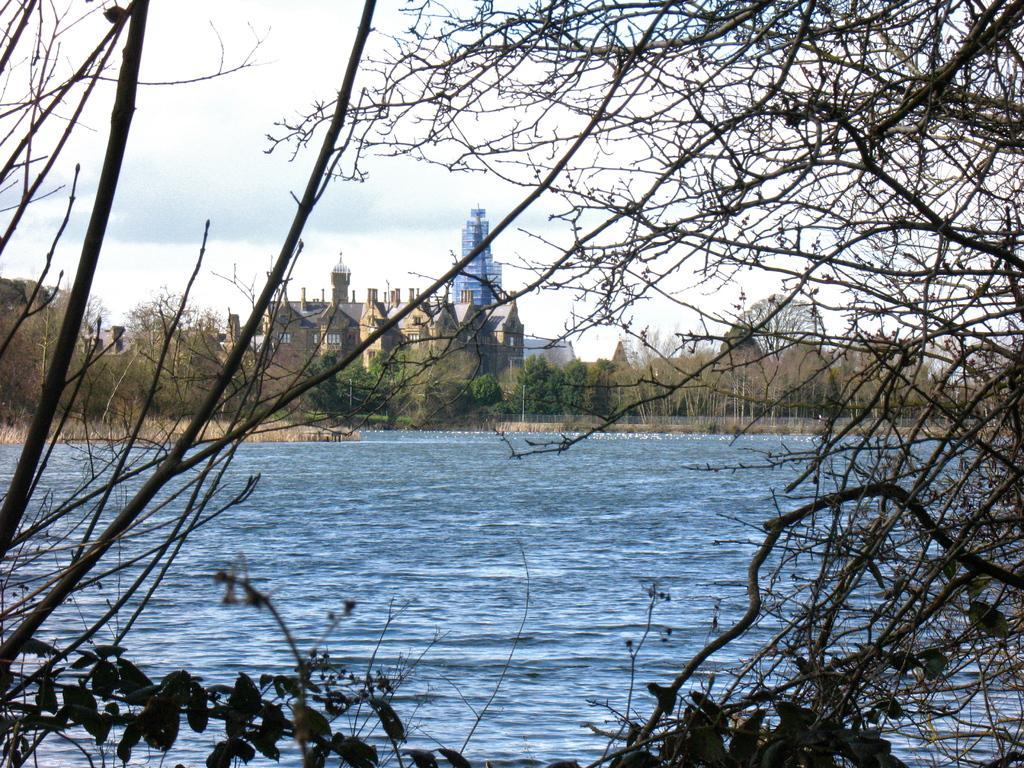Please provide a concise description of this image. At the bottom there is water, these are the trees. In the middle there are buildings. At the top it is a cloudy sky. 